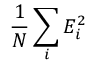<formula> <loc_0><loc_0><loc_500><loc_500>\frac { 1 } { N } \sum _ { i } E _ { i } ^ { 2 }</formula> 